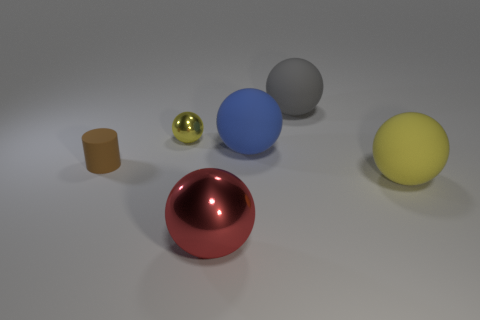Are any tiny yellow metallic objects visible?
Your response must be concise. Yes. What number of objects are big objects that are on the right side of the red sphere or big green cylinders?
Make the answer very short. 3. There is a tiny matte thing; is its color the same as the matte object that is in front of the small cylinder?
Provide a succinct answer. No. Is there a blue object of the same size as the brown matte object?
Make the answer very short. No. What is the material of the large blue sphere that is behind the rubber object on the left side of the large blue matte object?
Provide a short and direct response. Rubber. What number of large matte balls have the same color as the small rubber object?
Make the answer very short. 0. What is the shape of the tiny yellow object that is the same material as the large red object?
Provide a succinct answer. Sphere. There is a object to the left of the small yellow metal thing; what is its size?
Make the answer very short. Small. Are there an equal number of large blue matte spheres behind the small metal ball and large balls that are in front of the big shiny thing?
Your response must be concise. Yes. There is a matte sphere on the right side of the big thing behind the yellow thing that is to the left of the large red sphere; what color is it?
Your answer should be compact. Yellow. 